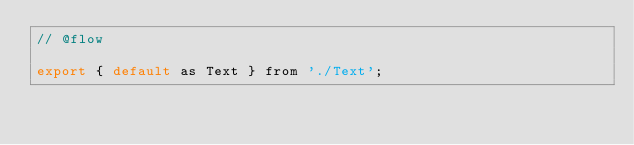Convert code to text. <code><loc_0><loc_0><loc_500><loc_500><_JavaScript_>// @flow

export { default as Text } from './Text';
</code> 